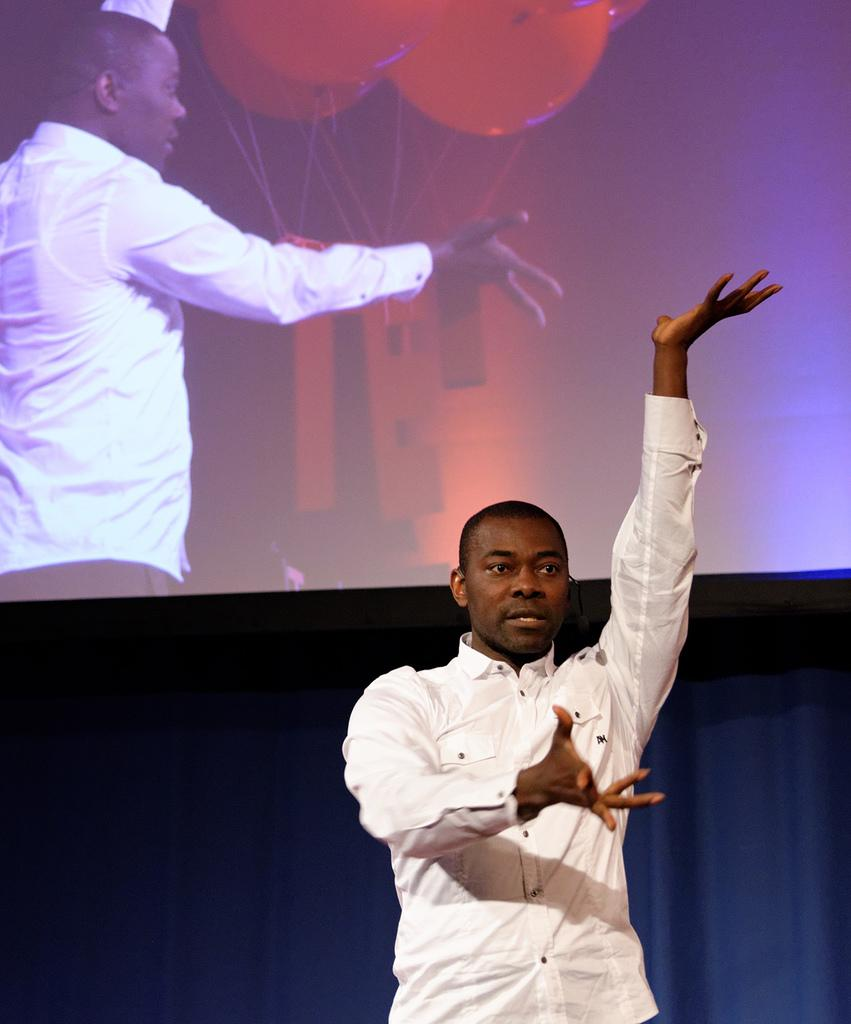What is the main subject in the foreground of the image? There is a person standing in the foreground of the image. What can be seen in the background of the image? There is a screen in the background of the image. What is displayed on the screen? The screen displays a person and balloons. Can you hear the person whistling in the image? There is no sound or indication of whistling in the image. How many toes does the person on the screen have? The image does not provide enough detail to determine the number of toes on the person displayed on the screen. 